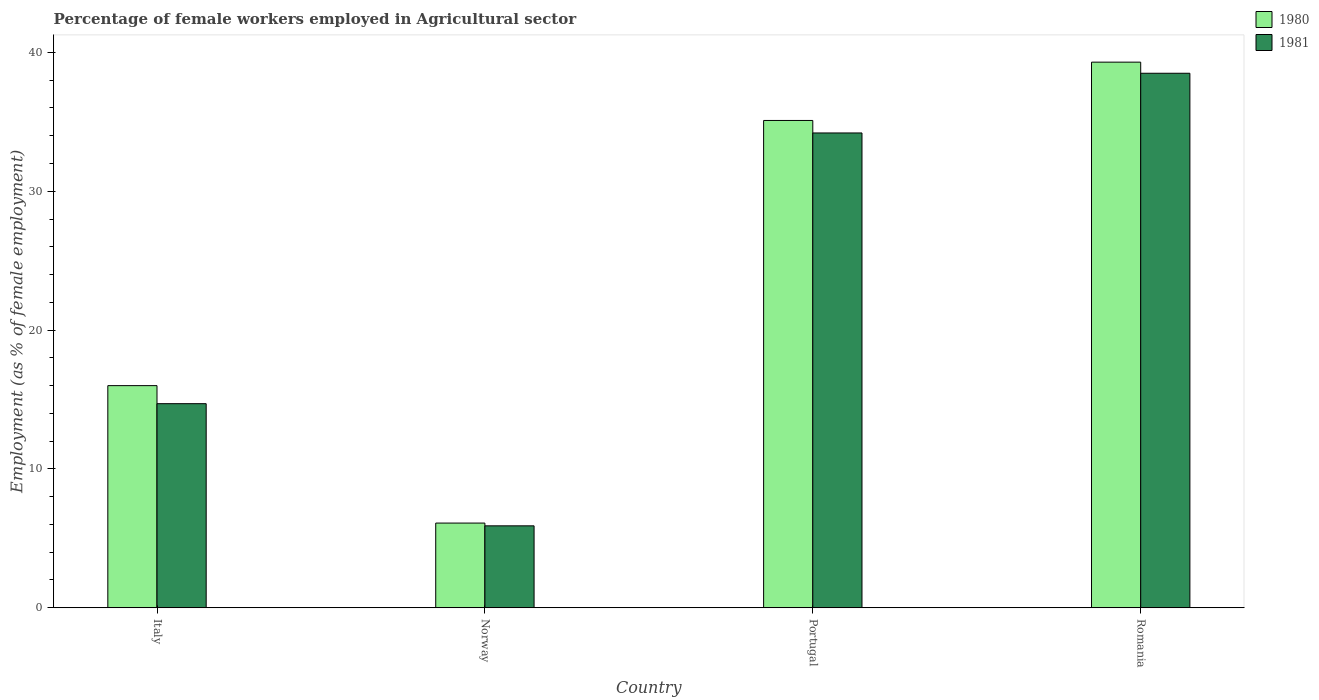How many groups of bars are there?
Your answer should be compact. 4. Are the number of bars per tick equal to the number of legend labels?
Provide a short and direct response. Yes. Are the number of bars on each tick of the X-axis equal?
Offer a very short reply. Yes. How many bars are there on the 4th tick from the left?
Make the answer very short. 2. What is the label of the 4th group of bars from the left?
Make the answer very short. Romania. In how many cases, is the number of bars for a given country not equal to the number of legend labels?
Keep it short and to the point. 0. What is the percentage of females employed in Agricultural sector in 1981 in Norway?
Your answer should be very brief. 5.9. Across all countries, what is the maximum percentage of females employed in Agricultural sector in 1980?
Your answer should be very brief. 39.3. Across all countries, what is the minimum percentage of females employed in Agricultural sector in 1980?
Provide a short and direct response. 6.1. In which country was the percentage of females employed in Agricultural sector in 1981 maximum?
Your answer should be compact. Romania. In which country was the percentage of females employed in Agricultural sector in 1980 minimum?
Ensure brevity in your answer.  Norway. What is the total percentage of females employed in Agricultural sector in 1980 in the graph?
Provide a succinct answer. 96.5. What is the difference between the percentage of females employed in Agricultural sector in 1981 in Norway and that in Romania?
Keep it short and to the point. -32.6. What is the difference between the percentage of females employed in Agricultural sector in 1980 in Portugal and the percentage of females employed in Agricultural sector in 1981 in Norway?
Your response must be concise. 29.2. What is the average percentage of females employed in Agricultural sector in 1981 per country?
Offer a terse response. 23.33. What is the difference between the percentage of females employed in Agricultural sector of/in 1980 and percentage of females employed in Agricultural sector of/in 1981 in Portugal?
Provide a succinct answer. 0.9. In how many countries, is the percentage of females employed in Agricultural sector in 1980 greater than 22 %?
Ensure brevity in your answer.  2. What is the ratio of the percentage of females employed in Agricultural sector in 1980 in Norway to that in Portugal?
Provide a succinct answer. 0.17. Is the percentage of females employed in Agricultural sector in 1980 in Italy less than that in Portugal?
Provide a short and direct response. Yes. What is the difference between the highest and the second highest percentage of females employed in Agricultural sector in 1980?
Give a very brief answer. -19.1. What is the difference between the highest and the lowest percentage of females employed in Agricultural sector in 1980?
Provide a succinct answer. 33.2. What does the 2nd bar from the left in Italy represents?
Your answer should be compact. 1981. How many bars are there?
Ensure brevity in your answer.  8. Where does the legend appear in the graph?
Your answer should be very brief. Top right. How many legend labels are there?
Your answer should be very brief. 2. What is the title of the graph?
Offer a terse response. Percentage of female workers employed in Agricultural sector. What is the label or title of the Y-axis?
Provide a short and direct response. Employment (as % of female employment). What is the Employment (as % of female employment) of 1980 in Italy?
Ensure brevity in your answer.  16. What is the Employment (as % of female employment) in 1981 in Italy?
Keep it short and to the point. 14.7. What is the Employment (as % of female employment) in 1980 in Norway?
Make the answer very short. 6.1. What is the Employment (as % of female employment) of 1981 in Norway?
Give a very brief answer. 5.9. What is the Employment (as % of female employment) of 1980 in Portugal?
Make the answer very short. 35.1. What is the Employment (as % of female employment) in 1981 in Portugal?
Your answer should be compact. 34.2. What is the Employment (as % of female employment) in 1980 in Romania?
Ensure brevity in your answer.  39.3. What is the Employment (as % of female employment) of 1981 in Romania?
Your answer should be very brief. 38.5. Across all countries, what is the maximum Employment (as % of female employment) of 1980?
Provide a short and direct response. 39.3. Across all countries, what is the maximum Employment (as % of female employment) in 1981?
Give a very brief answer. 38.5. Across all countries, what is the minimum Employment (as % of female employment) in 1980?
Your answer should be very brief. 6.1. Across all countries, what is the minimum Employment (as % of female employment) in 1981?
Make the answer very short. 5.9. What is the total Employment (as % of female employment) in 1980 in the graph?
Give a very brief answer. 96.5. What is the total Employment (as % of female employment) in 1981 in the graph?
Give a very brief answer. 93.3. What is the difference between the Employment (as % of female employment) in 1980 in Italy and that in Portugal?
Provide a succinct answer. -19.1. What is the difference between the Employment (as % of female employment) in 1981 in Italy and that in Portugal?
Keep it short and to the point. -19.5. What is the difference between the Employment (as % of female employment) in 1980 in Italy and that in Romania?
Ensure brevity in your answer.  -23.3. What is the difference between the Employment (as % of female employment) of 1981 in Italy and that in Romania?
Offer a terse response. -23.8. What is the difference between the Employment (as % of female employment) in 1981 in Norway and that in Portugal?
Provide a succinct answer. -28.3. What is the difference between the Employment (as % of female employment) of 1980 in Norway and that in Romania?
Give a very brief answer. -33.2. What is the difference between the Employment (as % of female employment) of 1981 in Norway and that in Romania?
Your response must be concise. -32.6. What is the difference between the Employment (as % of female employment) of 1981 in Portugal and that in Romania?
Provide a short and direct response. -4.3. What is the difference between the Employment (as % of female employment) in 1980 in Italy and the Employment (as % of female employment) in 1981 in Norway?
Your answer should be very brief. 10.1. What is the difference between the Employment (as % of female employment) in 1980 in Italy and the Employment (as % of female employment) in 1981 in Portugal?
Offer a terse response. -18.2. What is the difference between the Employment (as % of female employment) in 1980 in Italy and the Employment (as % of female employment) in 1981 in Romania?
Give a very brief answer. -22.5. What is the difference between the Employment (as % of female employment) of 1980 in Norway and the Employment (as % of female employment) of 1981 in Portugal?
Provide a short and direct response. -28.1. What is the difference between the Employment (as % of female employment) in 1980 in Norway and the Employment (as % of female employment) in 1981 in Romania?
Ensure brevity in your answer.  -32.4. What is the difference between the Employment (as % of female employment) in 1980 in Portugal and the Employment (as % of female employment) in 1981 in Romania?
Your answer should be very brief. -3.4. What is the average Employment (as % of female employment) in 1980 per country?
Ensure brevity in your answer.  24.12. What is the average Employment (as % of female employment) of 1981 per country?
Provide a succinct answer. 23.32. What is the ratio of the Employment (as % of female employment) in 1980 in Italy to that in Norway?
Your answer should be very brief. 2.62. What is the ratio of the Employment (as % of female employment) of 1981 in Italy to that in Norway?
Provide a short and direct response. 2.49. What is the ratio of the Employment (as % of female employment) of 1980 in Italy to that in Portugal?
Keep it short and to the point. 0.46. What is the ratio of the Employment (as % of female employment) of 1981 in Italy to that in Portugal?
Keep it short and to the point. 0.43. What is the ratio of the Employment (as % of female employment) in 1980 in Italy to that in Romania?
Your response must be concise. 0.41. What is the ratio of the Employment (as % of female employment) of 1981 in Italy to that in Romania?
Provide a succinct answer. 0.38. What is the ratio of the Employment (as % of female employment) in 1980 in Norway to that in Portugal?
Offer a very short reply. 0.17. What is the ratio of the Employment (as % of female employment) in 1981 in Norway to that in Portugal?
Your answer should be very brief. 0.17. What is the ratio of the Employment (as % of female employment) of 1980 in Norway to that in Romania?
Make the answer very short. 0.16. What is the ratio of the Employment (as % of female employment) in 1981 in Norway to that in Romania?
Offer a very short reply. 0.15. What is the ratio of the Employment (as % of female employment) of 1980 in Portugal to that in Romania?
Offer a very short reply. 0.89. What is the ratio of the Employment (as % of female employment) of 1981 in Portugal to that in Romania?
Provide a succinct answer. 0.89. What is the difference between the highest and the lowest Employment (as % of female employment) in 1980?
Ensure brevity in your answer.  33.2. What is the difference between the highest and the lowest Employment (as % of female employment) in 1981?
Give a very brief answer. 32.6. 